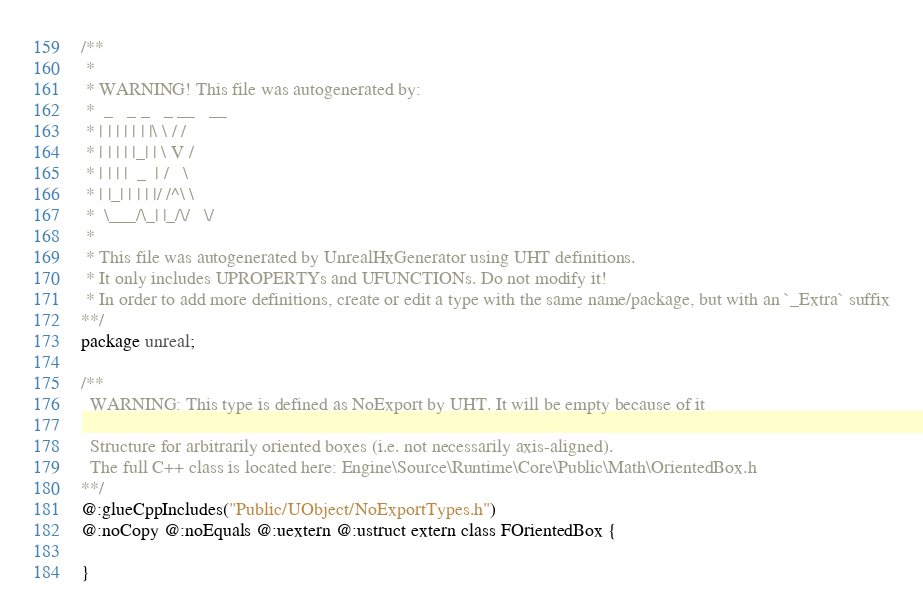<code> <loc_0><loc_0><loc_500><loc_500><_Haxe_>/**
 * 
 * WARNING! This file was autogenerated by: 
 *  _   _ _   _ __   __ 
 * | | | | | | |\ \ / / 
 * | | | | |_| | \ V /  
 * | | | |  _  | /   \  
 * | |_| | | | |/ /^\ \ 
 *  \___/\_| |_/\/   \/ 
 * 
 * This file was autogenerated by UnrealHxGenerator using UHT definitions.
 * It only includes UPROPERTYs and UFUNCTIONs. Do not modify it!
 * In order to add more definitions, create or edit a type with the same name/package, but with an `_Extra` suffix
**/
package unreal;

/**
  WARNING: This type is defined as NoExport by UHT. It will be empty because of it
  
  Structure for arbitrarily oriented boxes (i.e. not necessarily axis-aligned).
  The full C++ class is located here: Engine\Source\Runtime\Core\Public\Math\OrientedBox.h
**/
@:glueCppIncludes("Public/UObject/NoExportTypes.h")
@:noCopy @:noEquals @:uextern @:ustruct extern class FOrientedBox {
  
}
</code> 